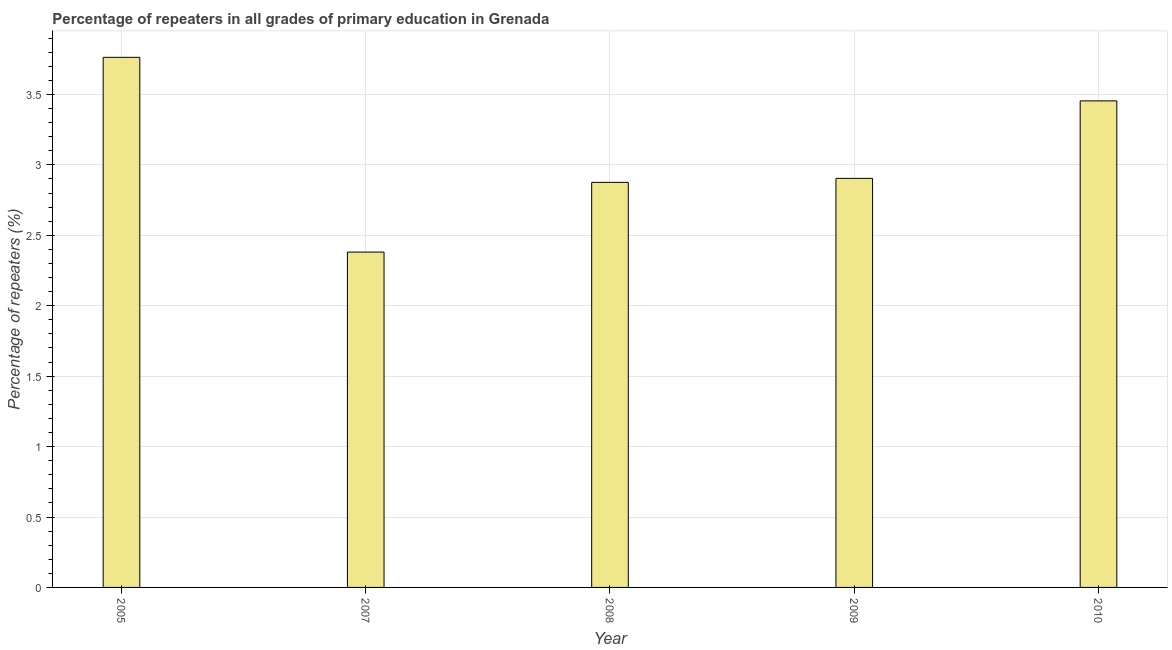Does the graph contain grids?
Make the answer very short. Yes. What is the title of the graph?
Provide a succinct answer. Percentage of repeaters in all grades of primary education in Grenada. What is the label or title of the Y-axis?
Provide a succinct answer. Percentage of repeaters (%). What is the percentage of repeaters in primary education in 2009?
Your answer should be compact. 2.9. Across all years, what is the maximum percentage of repeaters in primary education?
Your answer should be very brief. 3.76. Across all years, what is the minimum percentage of repeaters in primary education?
Make the answer very short. 2.38. In which year was the percentage of repeaters in primary education minimum?
Offer a very short reply. 2007. What is the sum of the percentage of repeaters in primary education?
Your answer should be compact. 15.38. What is the difference between the percentage of repeaters in primary education in 2005 and 2008?
Give a very brief answer. 0.89. What is the average percentage of repeaters in primary education per year?
Offer a terse response. 3.08. What is the median percentage of repeaters in primary education?
Keep it short and to the point. 2.9. In how many years, is the percentage of repeaters in primary education greater than 2.7 %?
Keep it short and to the point. 4. Do a majority of the years between 2008 and 2010 (inclusive) have percentage of repeaters in primary education greater than 0.9 %?
Offer a very short reply. Yes. What is the ratio of the percentage of repeaters in primary education in 2007 to that in 2009?
Give a very brief answer. 0.82. What is the difference between the highest and the second highest percentage of repeaters in primary education?
Give a very brief answer. 0.31. What is the difference between the highest and the lowest percentage of repeaters in primary education?
Make the answer very short. 1.38. How many bars are there?
Offer a very short reply. 5. Are all the bars in the graph horizontal?
Offer a terse response. No. How many years are there in the graph?
Provide a short and direct response. 5. What is the Percentage of repeaters (%) of 2005?
Ensure brevity in your answer.  3.76. What is the Percentage of repeaters (%) of 2007?
Offer a terse response. 2.38. What is the Percentage of repeaters (%) in 2008?
Offer a very short reply. 2.88. What is the Percentage of repeaters (%) in 2009?
Provide a short and direct response. 2.9. What is the Percentage of repeaters (%) in 2010?
Offer a very short reply. 3.45. What is the difference between the Percentage of repeaters (%) in 2005 and 2007?
Your answer should be very brief. 1.38. What is the difference between the Percentage of repeaters (%) in 2005 and 2008?
Your answer should be very brief. 0.89. What is the difference between the Percentage of repeaters (%) in 2005 and 2009?
Provide a succinct answer. 0.86. What is the difference between the Percentage of repeaters (%) in 2005 and 2010?
Offer a terse response. 0.31. What is the difference between the Percentage of repeaters (%) in 2007 and 2008?
Your response must be concise. -0.49. What is the difference between the Percentage of repeaters (%) in 2007 and 2009?
Provide a short and direct response. -0.52. What is the difference between the Percentage of repeaters (%) in 2007 and 2010?
Your answer should be compact. -1.07. What is the difference between the Percentage of repeaters (%) in 2008 and 2009?
Offer a terse response. -0.03. What is the difference between the Percentage of repeaters (%) in 2008 and 2010?
Give a very brief answer. -0.58. What is the difference between the Percentage of repeaters (%) in 2009 and 2010?
Your response must be concise. -0.55. What is the ratio of the Percentage of repeaters (%) in 2005 to that in 2007?
Your answer should be compact. 1.58. What is the ratio of the Percentage of repeaters (%) in 2005 to that in 2008?
Your response must be concise. 1.31. What is the ratio of the Percentage of repeaters (%) in 2005 to that in 2009?
Give a very brief answer. 1.3. What is the ratio of the Percentage of repeaters (%) in 2005 to that in 2010?
Give a very brief answer. 1.09. What is the ratio of the Percentage of repeaters (%) in 2007 to that in 2008?
Provide a short and direct response. 0.83. What is the ratio of the Percentage of repeaters (%) in 2007 to that in 2009?
Offer a very short reply. 0.82. What is the ratio of the Percentage of repeaters (%) in 2007 to that in 2010?
Provide a succinct answer. 0.69. What is the ratio of the Percentage of repeaters (%) in 2008 to that in 2010?
Offer a terse response. 0.83. What is the ratio of the Percentage of repeaters (%) in 2009 to that in 2010?
Your answer should be compact. 0.84. 